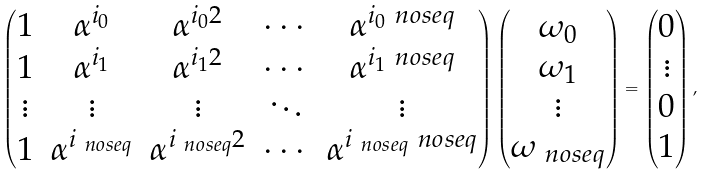Convert formula to latex. <formula><loc_0><loc_0><loc_500><loc_500>\begin{pmatrix} 1 & \alpha ^ { i _ { 0 } } & \alpha ^ { i _ { 0 } 2 } & \cdots & \alpha ^ { i _ { 0 } \ n o s e q } \\ 1 & \alpha ^ { i _ { 1 } } & \alpha ^ { i _ { 1 } 2 } & \cdots & \alpha ^ { i _ { 1 } \ n o s e q } \\ \vdots & \vdots & \vdots & \ddots & \vdots \\ 1 & \alpha ^ { i _ { \ n o s e q } } & \alpha ^ { i _ { \ n o s e q } 2 } & \cdots & \alpha ^ { i _ { \ n o s e q } \ n o s e q } \\ \end{pmatrix} \begin{pmatrix} \omega _ { 0 } \\ \omega _ { 1 } \\ \vdots \\ \omega _ { \ n o s e q } \end{pmatrix} = \begin{pmatrix} 0 \\ \vdots \\ 0 \\ 1 \end{pmatrix} ,</formula> 